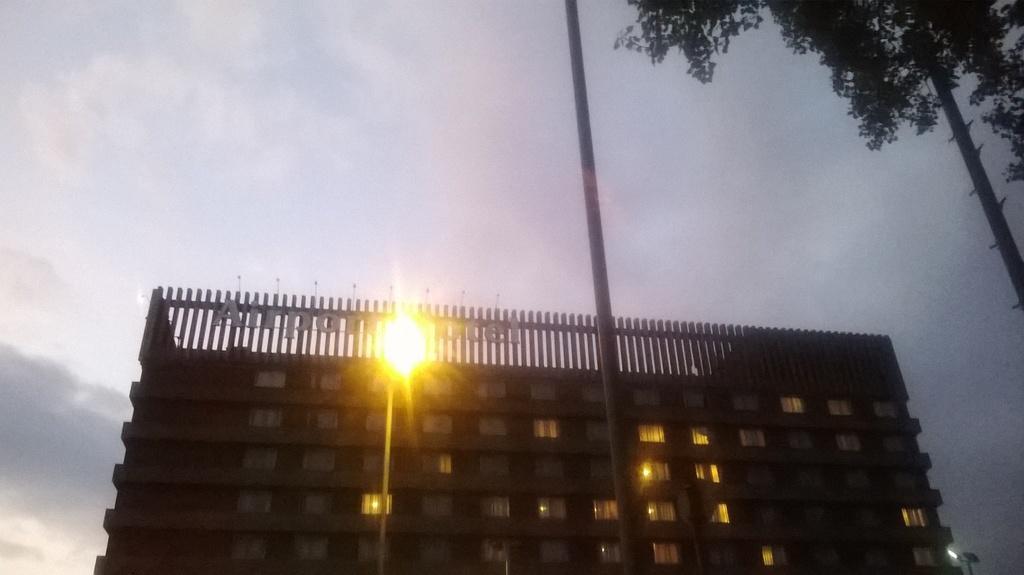Could you give a brief overview of what you see in this image? In this image we can see a building with windows, lights and railings. There is a light pole. And there is another pole. On the right side there is a tree. In the background there is sky with clouds. 